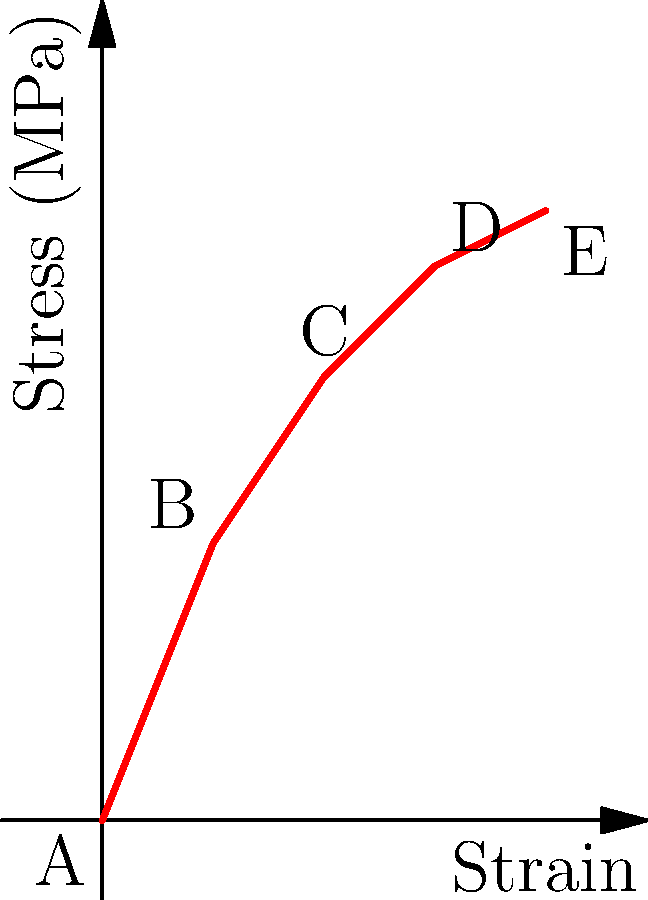As an astronaut familiar with spacesuit materials, analyze the stress-strain curve shown above. Which region (A-B, B-C, C-D, or D-E) represents the elastic limit of the material, and why is this property crucial for spacesuit design? To answer this question, let's analyze the stress-strain curve and its implications for spacesuit materials:

1. Region A-B: This is the linear elastic region, where stress is proportional to strain. The material will return to its original shape when the stress is removed.

2. Region B-C: This is the elastic limit or yield point. It's the maximum stress the material can withstand without permanent deformation.

3. Region C-D: This is the plastic deformation region, where the material experiences permanent changes in shape.

4. Region D-E: This is the strain hardening region, where the material becomes stronger but less ductile.

The elastic limit (Region B-C) is crucial for spacesuit design because:

a) It determines the maximum stress the material can handle while maintaining its original shape.
b) It ensures the spacesuit can withstand the pressures of space without permanent deformation.
c) It allows the suit to flex and move with the astronaut's body while maintaining its protective properties.
d) It helps prevent material fatigue and ensures the longevity of the spacesuit.

In spacesuit design, materials with a high elastic limit are preferred as they can withstand greater stresses without compromising the suit's integrity or the astronaut's safety.
Answer: Region B-C; it ensures maximum stress tolerance without permanent deformation, crucial for spacesuit flexibility and durability in space. 